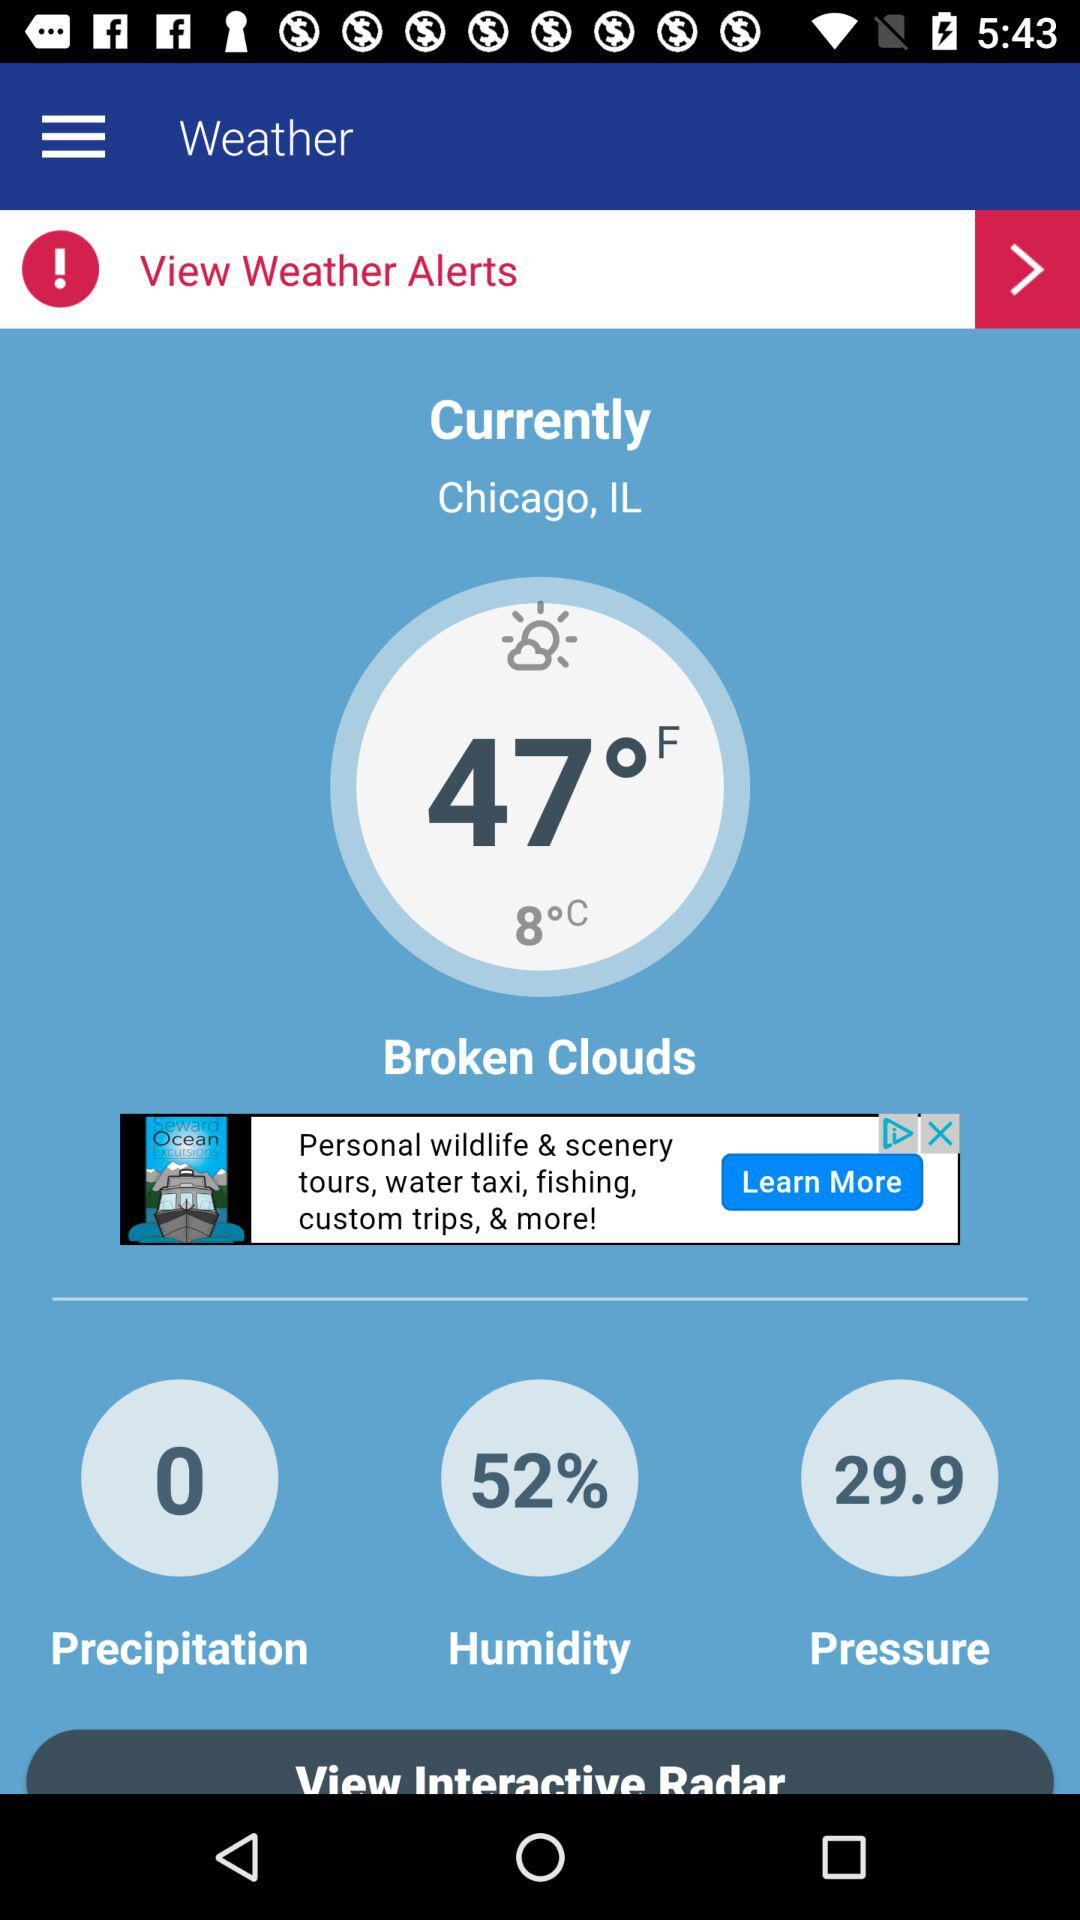What is the pressure? The pressure is 29.9. 